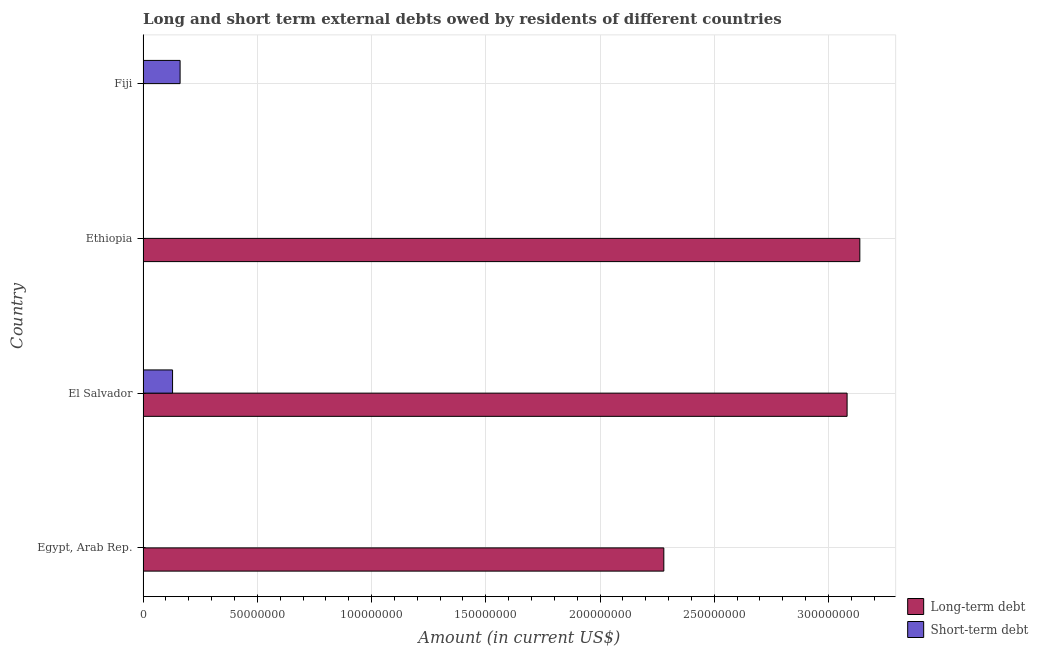How many bars are there on the 2nd tick from the top?
Keep it short and to the point. 1. How many bars are there on the 3rd tick from the bottom?
Provide a short and direct response. 1. What is the label of the 4th group of bars from the top?
Your answer should be compact. Egypt, Arab Rep. Across all countries, what is the maximum short-term debts owed by residents?
Give a very brief answer. 1.62e+07. In which country was the short-term debts owed by residents maximum?
Provide a short and direct response. Fiji. What is the total long-term debts owed by residents in the graph?
Give a very brief answer. 8.50e+08. What is the average long-term debts owed by residents per country?
Give a very brief answer. 2.12e+08. What is the difference between the short-term debts owed by residents and long-term debts owed by residents in El Salvador?
Your answer should be very brief. -2.95e+08. In how many countries, is the long-term debts owed by residents greater than 130000000 US$?
Offer a very short reply. 3. What is the ratio of the long-term debts owed by residents in Egypt, Arab Rep. to that in Ethiopia?
Provide a succinct answer. 0.73. Is the long-term debts owed by residents in El Salvador less than that in Ethiopia?
Your response must be concise. Yes. What is the difference between the highest and the second highest long-term debts owed by residents?
Provide a short and direct response. 5.57e+06. What is the difference between the highest and the lowest long-term debts owed by residents?
Provide a short and direct response. 3.14e+08. In how many countries, is the short-term debts owed by residents greater than the average short-term debts owed by residents taken over all countries?
Provide a short and direct response. 2. Is the sum of the long-term debts owed by residents in Egypt, Arab Rep. and El Salvador greater than the maximum short-term debts owed by residents across all countries?
Provide a succinct answer. Yes. Are all the bars in the graph horizontal?
Your answer should be very brief. Yes. What is the difference between two consecutive major ticks on the X-axis?
Ensure brevity in your answer.  5.00e+07. Are the values on the major ticks of X-axis written in scientific E-notation?
Your answer should be compact. No. Where does the legend appear in the graph?
Provide a succinct answer. Bottom right. How many legend labels are there?
Offer a terse response. 2. What is the title of the graph?
Keep it short and to the point. Long and short term external debts owed by residents of different countries. Does "Pregnant women" appear as one of the legend labels in the graph?
Make the answer very short. No. What is the label or title of the Y-axis?
Make the answer very short. Country. What is the Amount (in current US$) in Long-term debt in Egypt, Arab Rep.?
Keep it short and to the point. 2.28e+08. What is the Amount (in current US$) of Long-term debt in El Salvador?
Offer a very short reply. 3.08e+08. What is the Amount (in current US$) in Short-term debt in El Salvador?
Your answer should be compact. 1.29e+07. What is the Amount (in current US$) of Long-term debt in Ethiopia?
Provide a short and direct response. 3.14e+08. What is the Amount (in current US$) of Short-term debt in Fiji?
Offer a terse response. 1.62e+07. Across all countries, what is the maximum Amount (in current US$) of Long-term debt?
Your answer should be compact. 3.14e+08. Across all countries, what is the maximum Amount (in current US$) of Short-term debt?
Your answer should be compact. 1.62e+07. Across all countries, what is the minimum Amount (in current US$) in Long-term debt?
Your answer should be compact. 0. What is the total Amount (in current US$) of Long-term debt in the graph?
Provide a succinct answer. 8.50e+08. What is the total Amount (in current US$) in Short-term debt in the graph?
Your answer should be very brief. 2.91e+07. What is the difference between the Amount (in current US$) in Long-term debt in Egypt, Arab Rep. and that in El Salvador?
Offer a terse response. -8.02e+07. What is the difference between the Amount (in current US$) of Long-term debt in Egypt, Arab Rep. and that in Ethiopia?
Make the answer very short. -8.58e+07. What is the difference between the Amount (in current US$) in Long-term debt in El Salvador and that in Ethiopia?
Provide a succinct answer. -5.57e+06. What is the difference between the Amount (in current US$) of Short-term debt in El Salvador and that in Fiji?
Keep it short and to the point. -3.30e+06. What is the difference between the Amount (in current US$) of Long-term debt in Egypt, Arab Rep. and the Amount (in current US$) of Short-term debt in El Salvador?
Give a very brief answer. 2.15e+08. What is the difference between the Amount (in current US$) in Long-term debt in Egypt, Arab Rep. and the Amount (in current US$) in Short-term debt in Fiji?
Your response must be concise. 2.12e+08. What is the difference between the Amount (in current US$) of Long-term debt in El Salvador and the Amount (in current US$) of Short-term debt in Fiji?
Provide a short and direct response. 2.92e+08. What is the difference between the Amount (in current US$) in Long-term debt in Ethiopia and the Amount (in current US$) in Short-term debt in Fiji?
Offer a very short reply. 2.97e+08. What is the average Amount (in current US$) in Long-term debt per country?
Provide a short and direct response. 2.12e+08. What is the average Amount (in current US$) of Short-term debt per country?
Keep it short and to the point. 7.28e+06. What is the difference between the Amount (in current US$) of Long-term debt and Amount (in current US$) of Short-term debt in El Salvador?
Offer a very short reply. 2.95e+08. What is the ratio of the Amount (in current US$) in Long-term debt in Egypt, Arab Rep. to that in El Salvador?
Your answer should be very brief. 0.74. What is the ratio of the Amount (in current US$) of Long-term debt in Egypt, Arab Rep. to that in Ethiopia?
Your answer should be very brief. 0.73. What is the ratio of the Amount (in current US$) of Long-term debt in El Salvador to that in Ethiopia?
Ensure brevity in your answer.  0.98. What is the ratio of the Amount (in current US$) of Short-term debt in El Salvador to that in Fiji?
Provide a short and direct response. 0.8. What is the difference between the highest and the second highest Amount (in current US$) in Long-term debt?
Ensure brevity in your answer.  5.57e+06. What is the difference between the highest and the lowest Amount (in current US$) of Long-term debt?
Provide a succinct answer. 3.14e+08. What is the difference between the highest and the lowest Amount (in current US$) in Short-term debt?
Make the answer very short. 1.62e+07. 